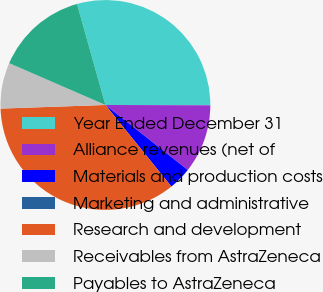Convert chart to OTSL. <chart><loc_0><loc_0><loc_500><loc_500><pie_chart><fcel>Year Ended December 31<fcel>Alliance revenues (net of<fcel>Materials and production costs<fcel>Marketing and administrative<fcel>Research and development<fcel>Receivables from AstraZeneca<fcel>Payables to AstraZeneca<nl><fcel>29.41%<fcel>10.59%<fcel>3.54%<fcel>0.01%<fcel>35.27%<fcel>7.07%<fcel>14.12%<nl></chart> 